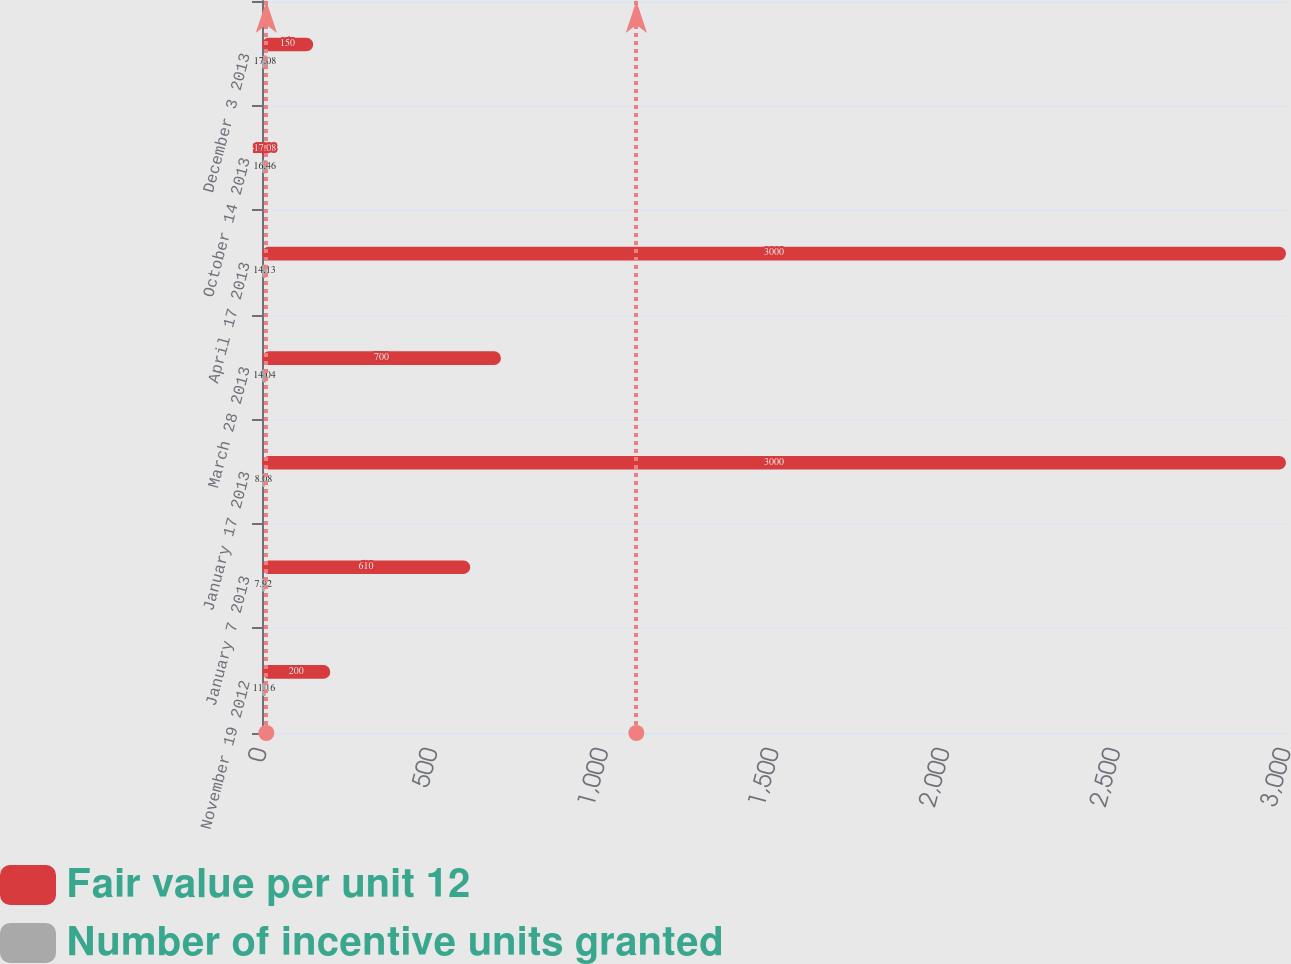Convert chart to OTSL. <chart><loc_0><loc_0><loc_500><loc_500><stacked_bar_chart><ecel><fcel>November 19 2012<fcel>January 7 2013<fcel>January 17 2013<fcel>March 28 2013<fcel>April 17 2013<fcel>October 14 2013<fcel>December 3 2013<nl><fcel>Fair value per unit 12<fcel>200<fcel>610<fcel>3000<fcel>700<fcel>3000<fcel>17.08<fcel>150<nl><fcel>Number of incentive units granted<fcel>11.16<fcel>7.92<fcel>8.08<fcel>14.04<fcel>14.13<fcel>16.46<fcel>17.08<nl></chart> 